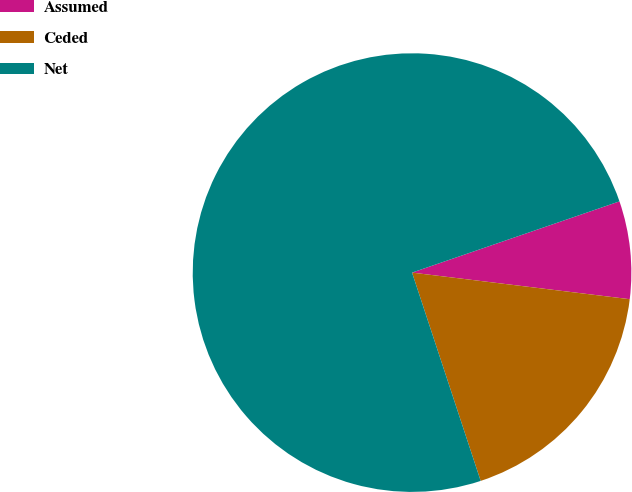Convert chart to OTSL. <chart><loc_0><loc_0><loc_500><loc_500><pie_chart><fcel>Assumed<fcel>Ceded<fcel>Net<nl><fcel>7.2%<fcel>18.0%<fcel>74.8%<nl></chart> 